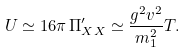<formula> <loc_0><loc_0><loc_500><loc_500>U \simeq 1 6 \pi \, \Pi ^ { \prime } _ { X X } \simeq \frac { g ^ { 2 } v ^ { 2 } } { m _ { 1 } ^ { 2 } } T .</formula> 